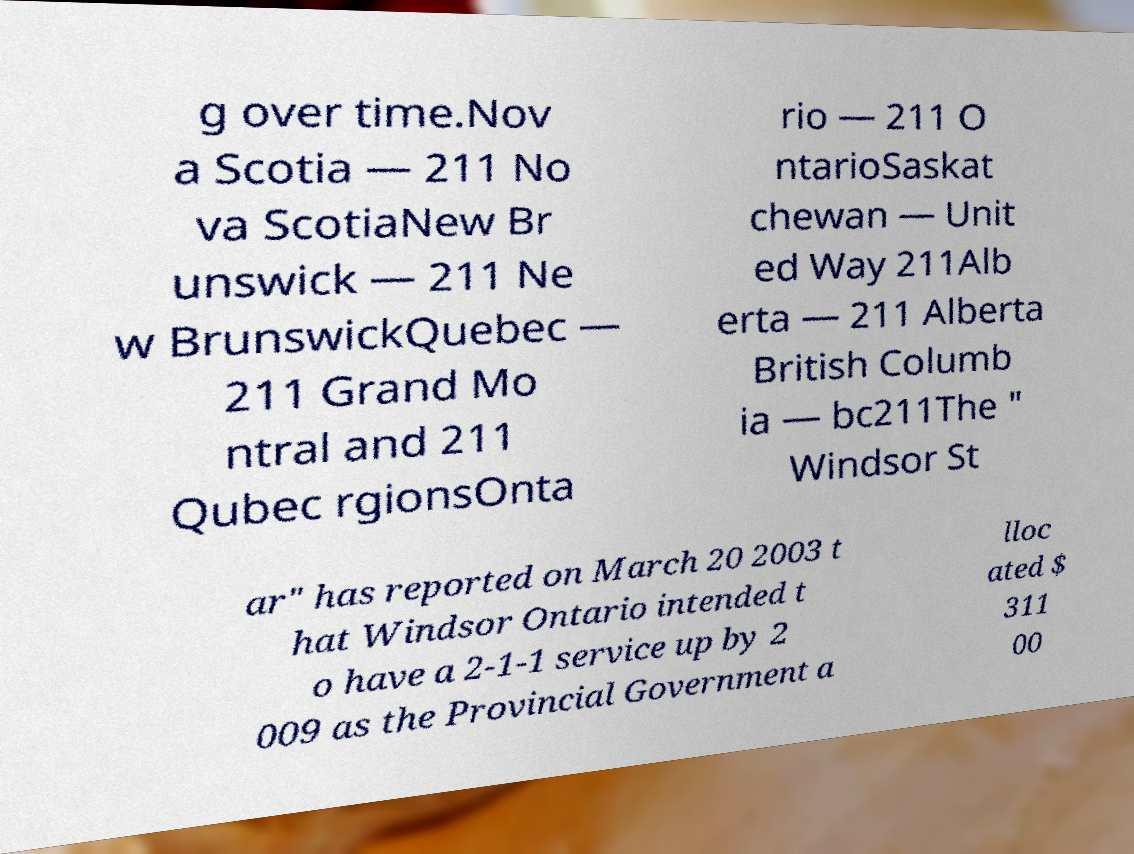Please read and relay the text visible in this image. What does it say? g over time.Nov a Scotia — 211 No va ScotiaNew Br unswick — 211 Ne w BrunswickQuebec — 211 Grand Mo ntral and 211 Qubec rgionsOnta rio — 211 O ntarioSaskat chewan — Unit ed Way 211Alb erta — 211 Alberta British Columb ia — bc211The " Windsor St ar" has reported on March 20 2003 t hat Windsor Ontario intended t o have a 2-1-1 service up by 2 009 as the Provincial Government a lloc ated $ 311 00 